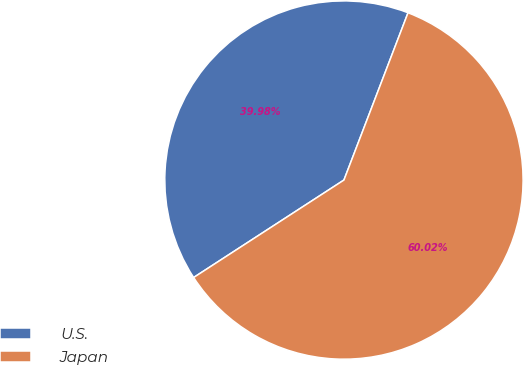<chart> <loc_0><loc_0><loc_500><loc_500><pie_chart><fcel>U.S.<fcel>Japan<nl><fcel>39.98%<fcel>60.02%<nl></chart> 